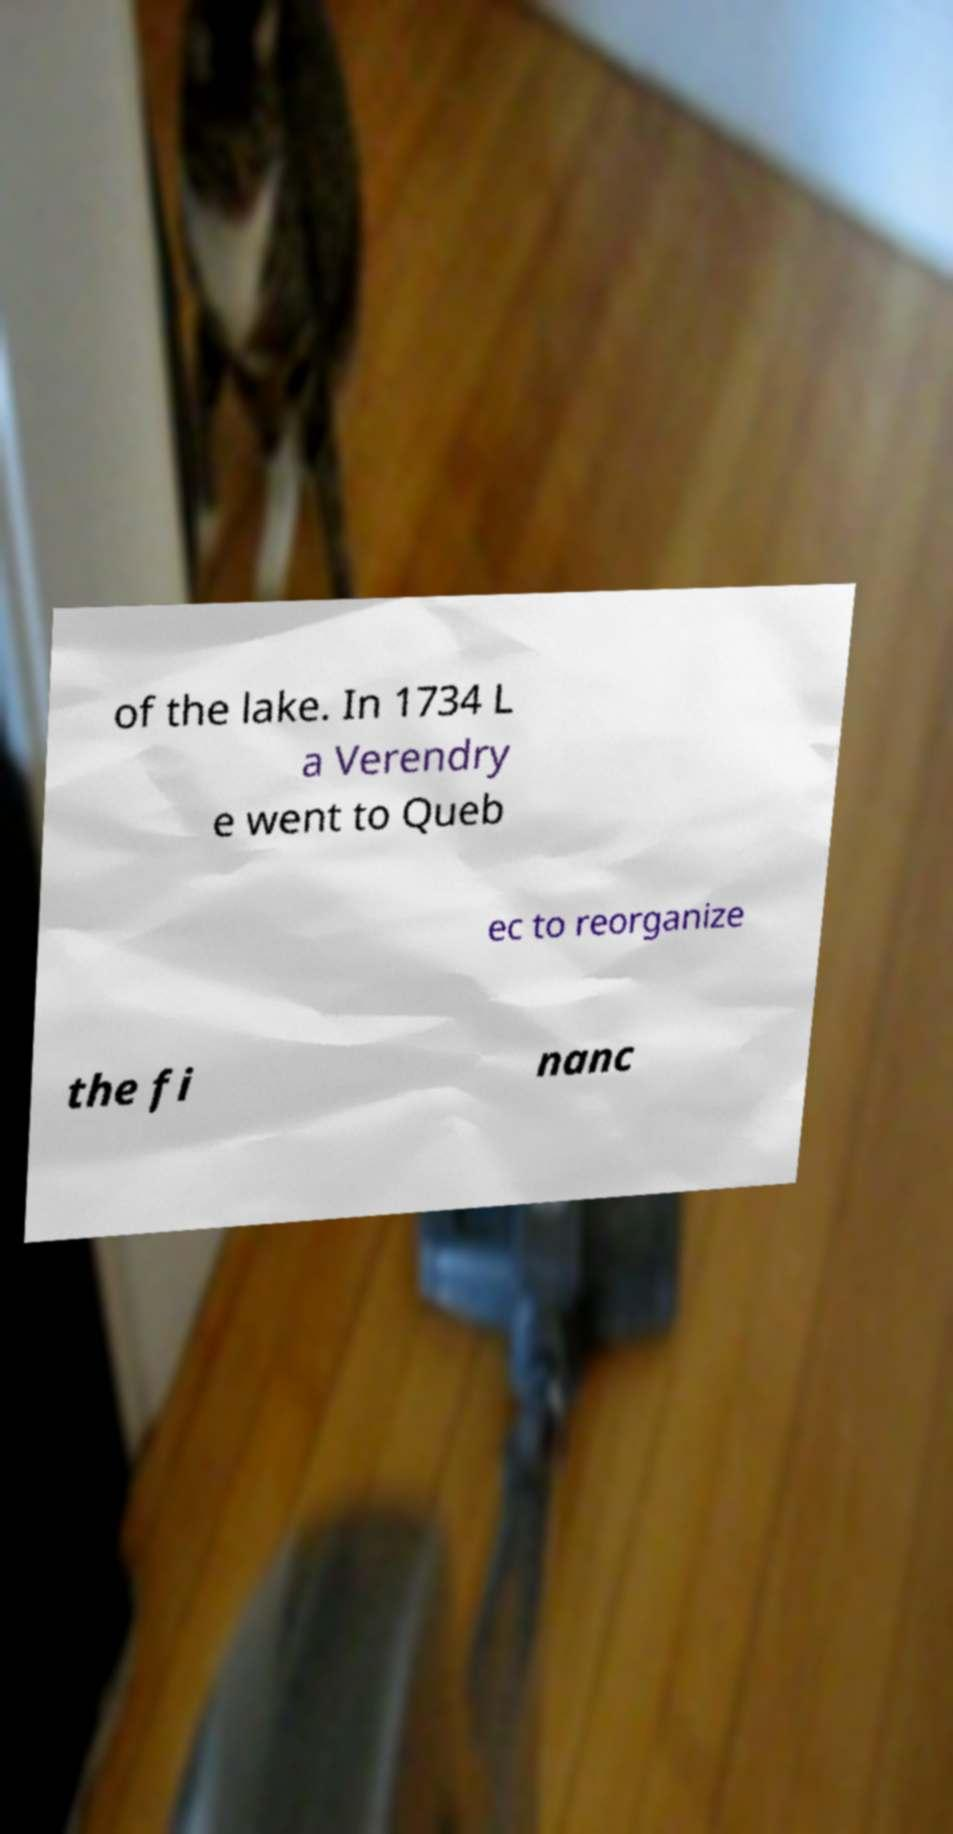Please read and relay the text visible in this image. What does it say? of the lake. In 1734 L a Verendry e went to Queb ec to reorganize the fi nanc 